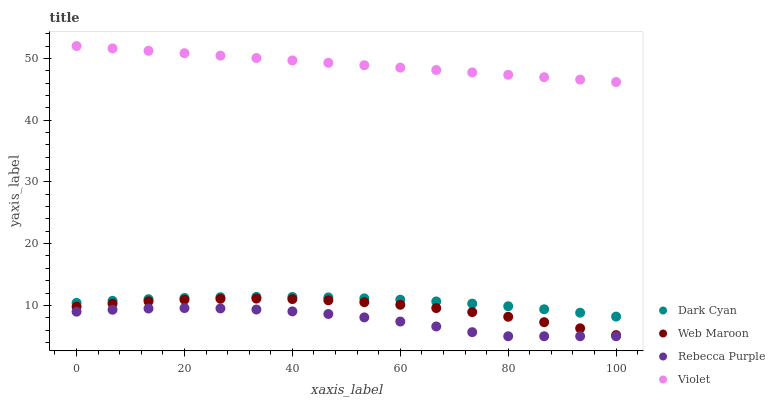Does Rebecca Purple have the minimum area under the curve?
Answer yes or no. Yes. Does Violet have the maximum area under the curve?
Answer yes or no. Yes. Does Web Maroon have the minimum area under the curve?
Answer yes or no. No. Does Web Maroon have the maximum area under the curve?
Answer yes or no. No. Is Violet the smoothest?
Answer yes or no. Yes. Is Rebecca Purple the roughest?
Answer yes or no. Yes. Is Web Maroon the smoothest?
Answer yes or no. No. Is Web Maroon the roughest?
Answer yes or no. No. Does Rebecca Purple have the lowest value?
Answer yes or no. Yes. Does Web Maroon have the lowest value?
Answer yes or no. No. Does Violet have the highest value?
Answer yes or no. Yes. Does Web Maroon have the highest value?
Answer yes or no. No. Is Rebecca Purple less than Web Maroon?
Answer yes or no. Yes. Is Dark Cyan greater than Rebecca Purple?
Answer yes or no. Yes. Does Rebecca Purple intersect Web Maroon?
Answer yes or no. No. 